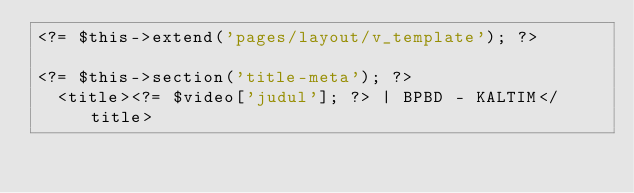Convert code to text. <code><loc_0><loc_0><loc_500><loc_500><_PHP_><?= $this->extend('pages/layout/v_template'); ?>

<?= $this->section('title-meta'); ?>
  <title><?= $video['judul']; ?> | BPBD - KALTIM</title></code> 